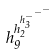<formula> <loc_0><loc_0><loc_500><loc_500>h _ { 9 } ^ { h _ { 2 } ^ { h _ { 3 } ^ { - ^ { - ^ { - } } } } }</formula> 